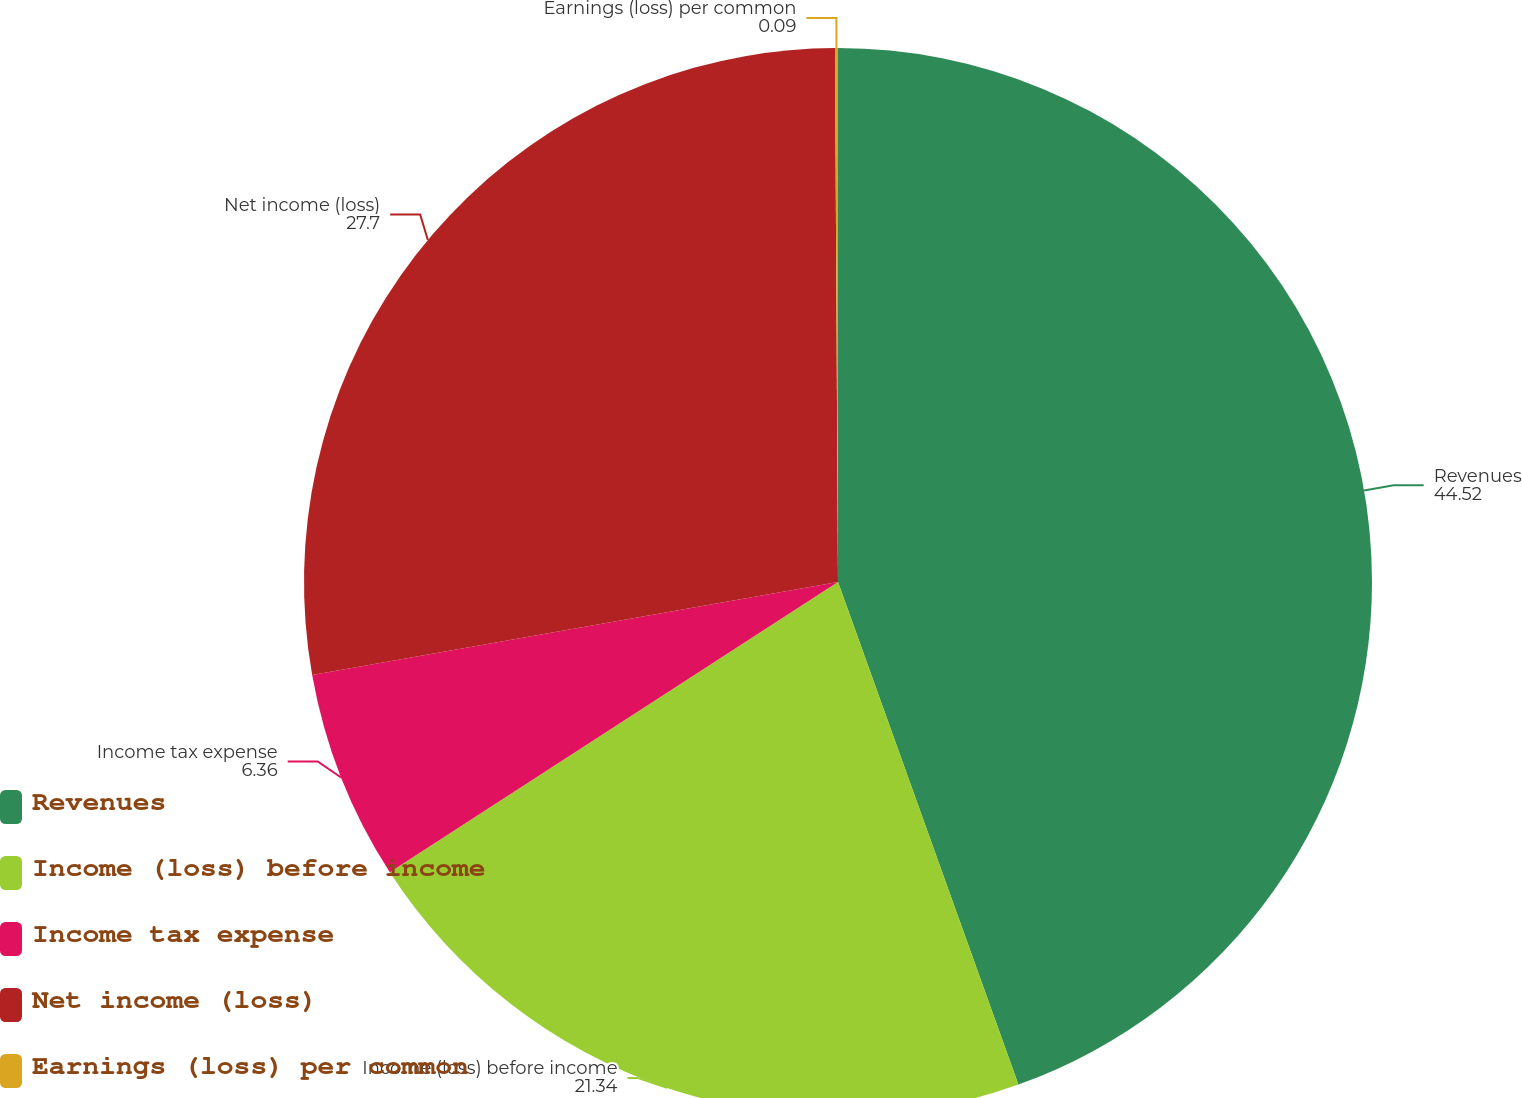Convert chart. <chart><loc_0><loc_0><loc_500><loc_500><pie_chart><fcel>Revenues<fcel>Income (loss) before income<fcel>Income tax expense<fcel>Net income (loss)<fcel>Earnings (loss) per common<nl><fcel>44.52%<fcel>21.34%<fcel>6.36%<fcel>27.7%<fcel>0.09%<nl></chart> 